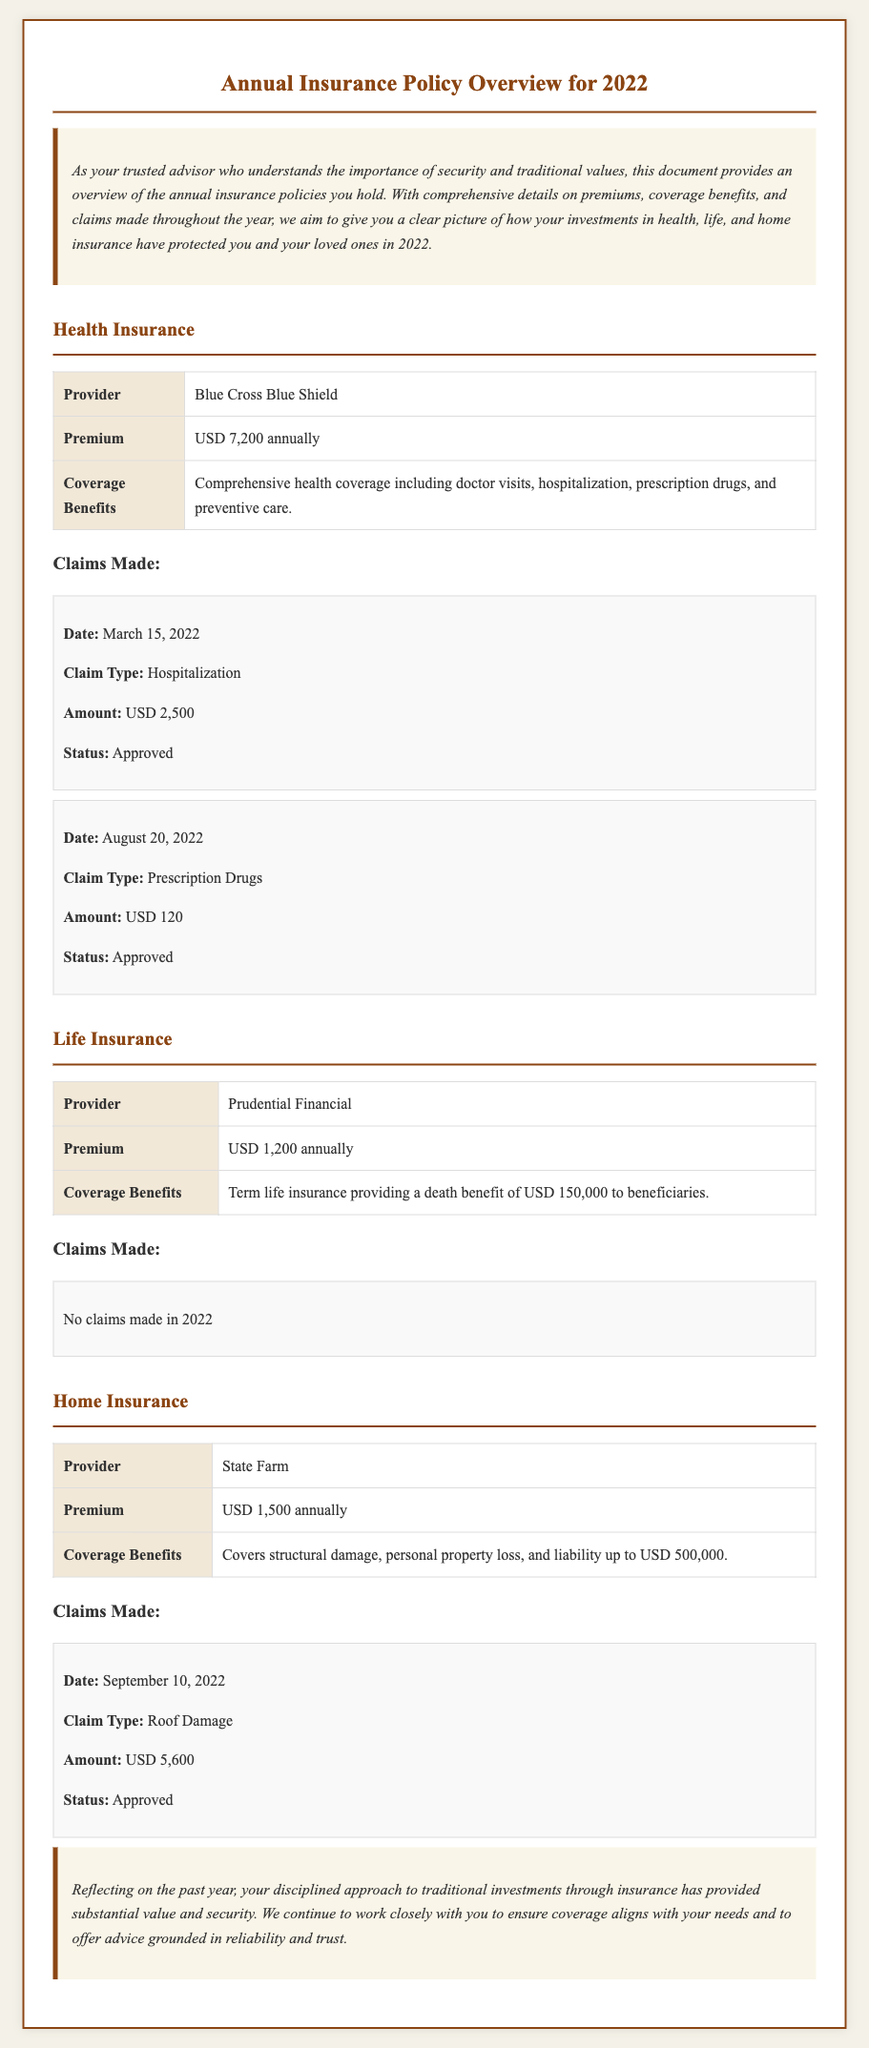What is the health insurance premium? The health insurance premium is stated clearly in the document, which shows a cost of USD 7,200 annually.
Answer: USD 7,200 Who is the provider for life insurance? The document specifies that Prudential Financial is the provider for life insurance plans.
Answer: Prudential Financial How much was claimed for roof damage in home insurance? The amount claimed for roof damage can be found under the home insurance claims section, which indicates it was USD 5,600.
Answer: USD 5,600 What is the death benefit amount for the life insurance policy? The life insurance section outlines a death benefit of USD 150,000 for beneficiaries, making it straightforward to identify.
Answer: USD 150,000 Which insurance type had no claims made in 2022? The life insurance section mentions there were no claims made, indicating its status during the year.
Answer: Life Insurance What is the coverage benefit for home insurance? The home insurance coverage benefits are detailed and include structural damage, personal property loss, and liability.
Answer: Covers structural damage, personal property loss, and liability up to USD 500,000 How many claims were made for health insurance? The claims section under health insurance lists two claims made during the year, providing a clear indication of activity.
Answer: Two claims What date was the hospitalization claim made? The health insurance claims section specifies that the hospitalization claim was submitted on March 15, 2022.
Answer: March 15, 2022 What is the total annual premium for home insurance? The document details the premium for home insurance as USD 1,500, easily located in the home insurance section.
Answer: USD 1,500 